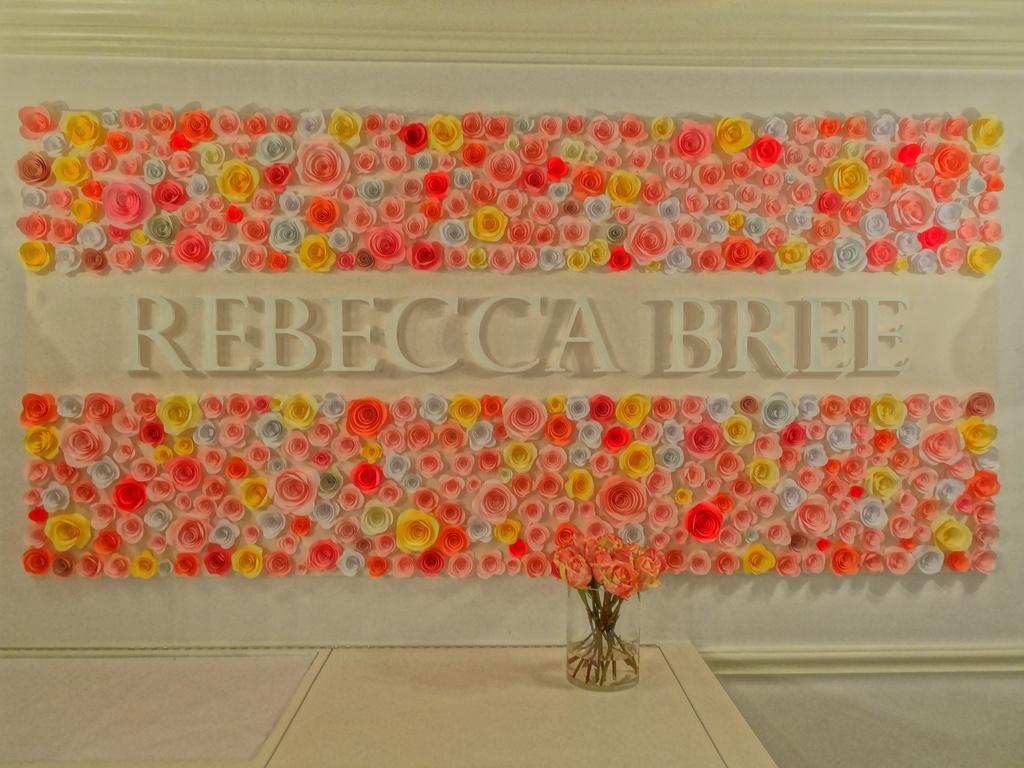How would you summarize this image in a sentence or two? In this image we can see a wall decorated with flowers and a glass container with flowers in it. 